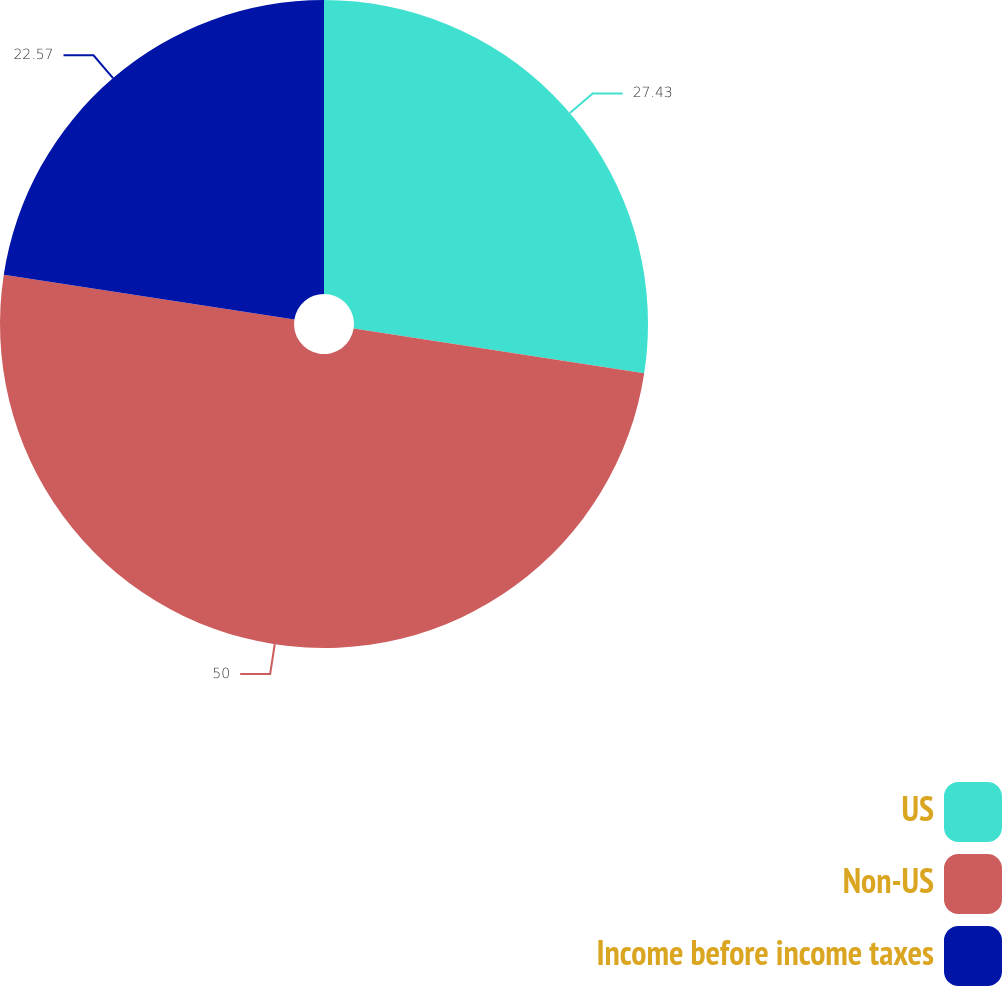Convert chart. <chart><loc_0><loc_0><loc_500><loc_500><pie_chart><fcel>US<fcel>Non-US<fcel>Income before income taxes<nl><fcel>27.43%<fcel>50.0%<fcel>22.57%<nl></chart> 